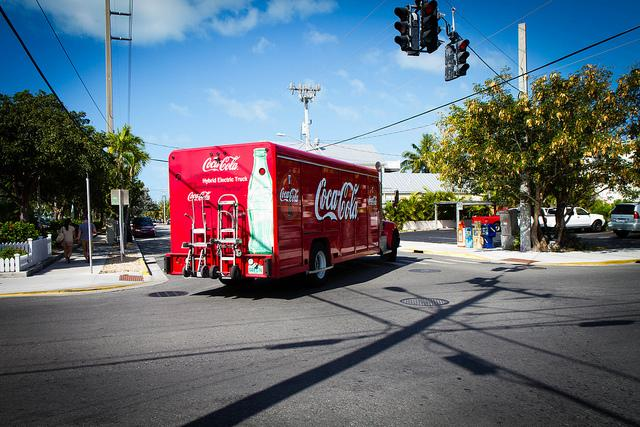Why is the truck in the middle of the street? turning left 